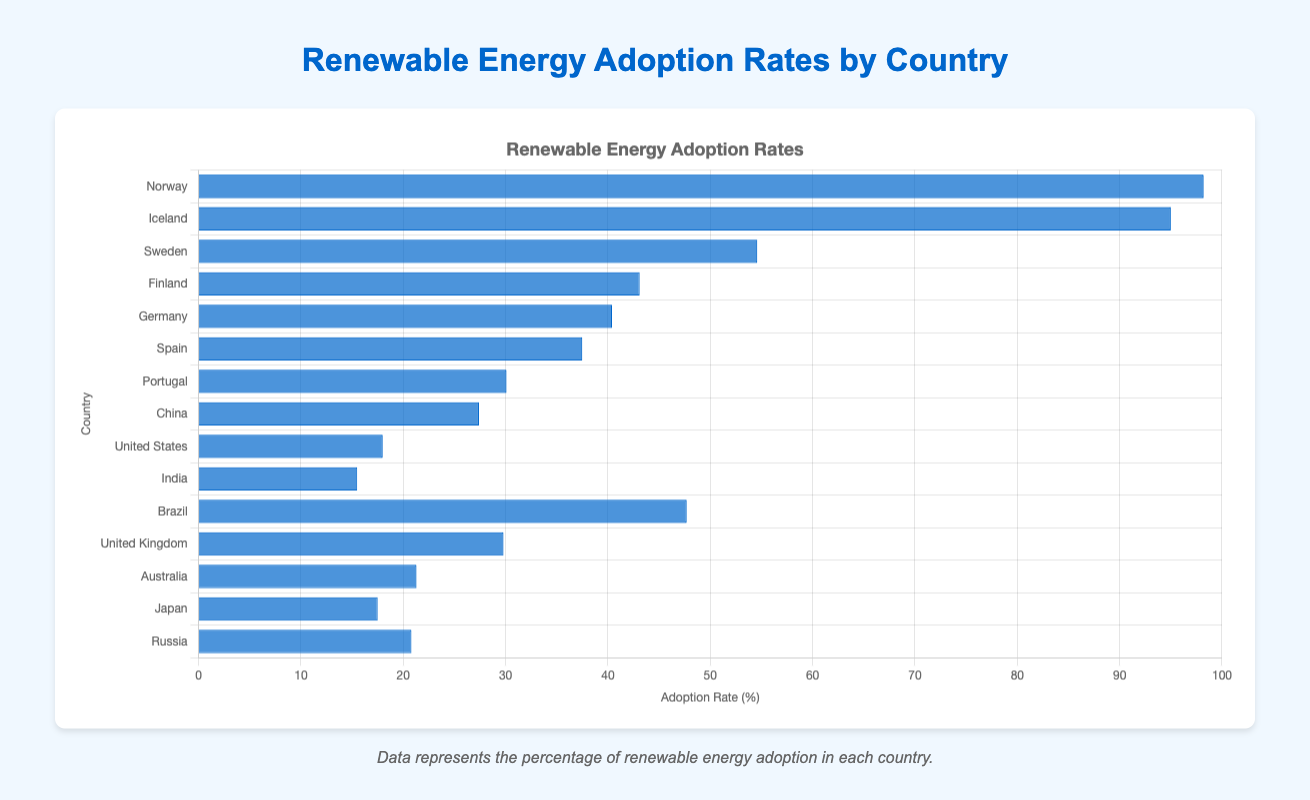What country has the highest renewable energy adoption rate? Looking at the bar chart, Norway has the tallest bar, which indicates it has the highest adoption rate of 98.2%.
Answer: Norway What country has the lowest renewable energy adoption rate? From the bar chart, the shortest bar belongs to India, which indicates it has the lowest adoption rate of 15.5%.
Answer: India Which countries have renewable energy adoption rates greater than 50%? From the chart, the bars for Norway, Iceland, and Sweden exceed the 50% mark.
Answer: Norway, Iceland, Sweden Compare the renewable energy adoption rates of the United States and China. The chart shows that China has a bar with a height representing 27.4%, while the United States has a bar representing 18.0%. Hence, China's rate is higher.
Answer: China > United States What is the combined renewable energy adoption rate of Germany and Spain? The adoption rate for Germany is 40.4% and Spain is 37.5%. Adding these rates gives 40.4 + 37.5 = 77.9%.
Answer: 77.9% What is the difference in renewable energy adoption rates between Brazil and Japan? Brazil's adoption rate is 47.7%, and Japan's rate is 17.5%. The difference is 47.7 - 17.5 = 30.2%.
Answer: 30.2% What is the average renewable energy adoption rate for European countries listed in the chart? (Consider Norway, Iceland, Sweden, Finland, Germany, Spain, Portugal, United Kingdom, and Russia) Adding the adoption rates: 98.2 + 95.0 + 54.6 + 43.1 + 40.4 + 37.5 + 30.1 + 29.8 + 20.8 = 449.5. Dividing by the 9 countries: 449.5 / 9 ≈ 49.94%.
Answer: 49.94% What is the visual representation of countries with adoption rates close to 30%? Portugal (30.1%), United Kingdom (29.8%). Both have bars of similar height, slightly below halfway to the 50% mark.
Answer: Portugal, United Kingdom Which country has an adoption rate closest to the global mean rate given in the chart? Calculating the mean: Sum of all rates (98.2 + 95 + 54.6 + 43.1 + 40.4 + 37.5 + 30.1 + 27.4 + 18 + 15.5 + 47.7 + 29.8 + 21.3 + 17.5 + 20.8) = 596.9. Mean = 596.9 / 15 ≈ 39.79%. Germany, with an adoption rate of 40.4%, is closest.
Answer: Germany Rank the countries in descending order of their renewable energy adoption rates. From highest to lowest, the bars correspond to: Norway (98.2%), Iceland (95.0%), Sweden (54.6%), Brazil (47.7%), Finland (43.1%), Germany (40.4%), Spain (37.5%), Portugal (30.1%), United Kingdom (29.8%), China (27.4%), Australia (21.3%), Russia (20.8%), United States (18.0%), Japan (17.5%), India (15.5%).
Answer: Norway, Iceland, Sweden, Brazil, Finland, Germany, Spain, Portugal, United Kingdom, China, Australia, Russia, United States, Japan, India 